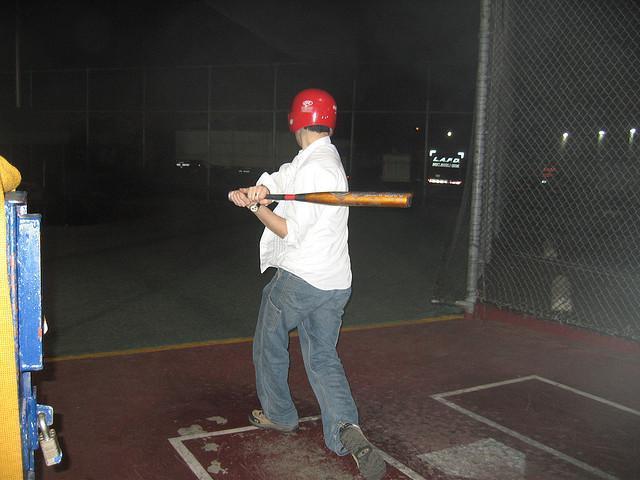How many snow skis do you see?
Give a very brief answer. 0. 